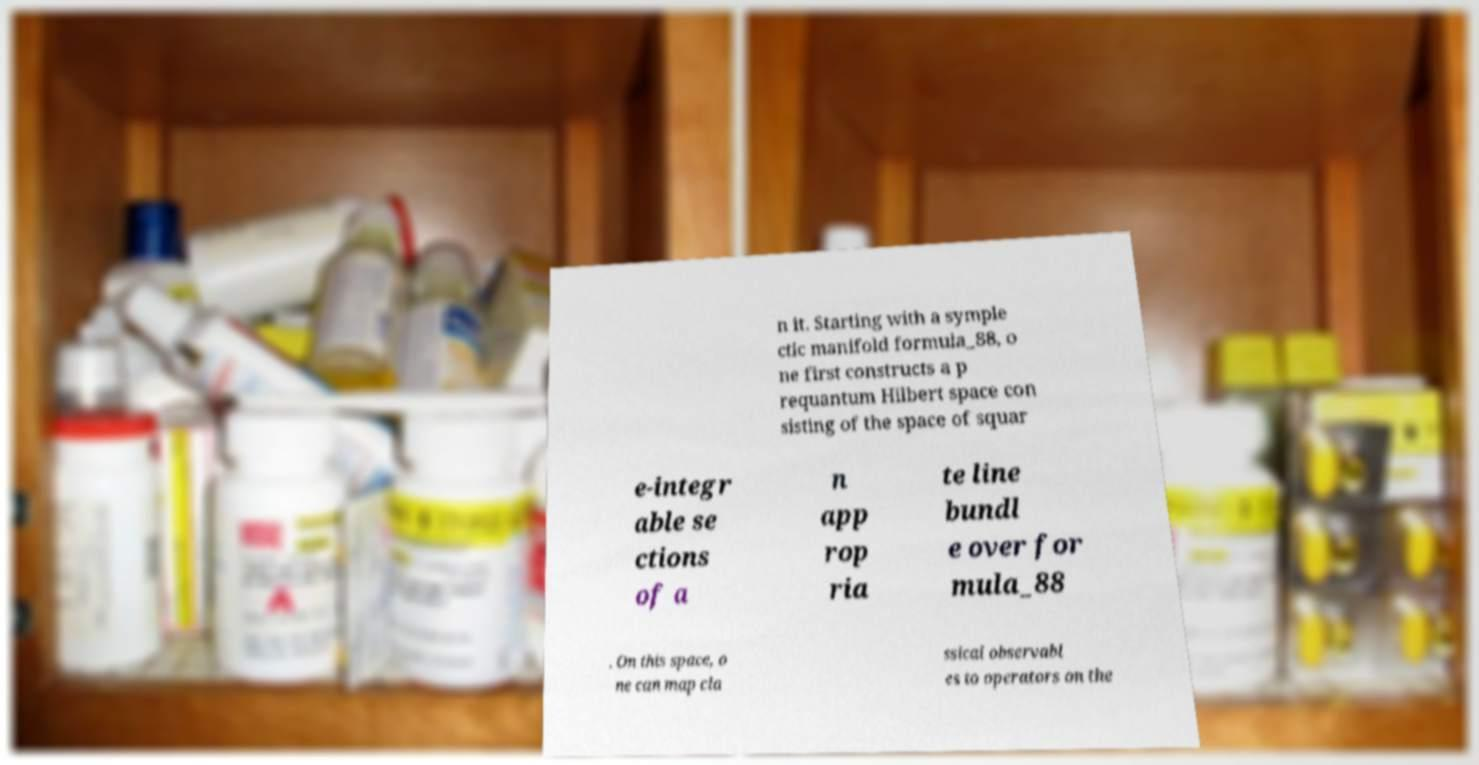There's text embedded in this image that I need extracted. Can you transcribe it verbatim? n it. Starting with a symple ctic manifold formula_88, o ne first constructs a p requantum Hilbert space con sisting of the space of squar e-integr able se ctions of a n app rop ria te line bundl e over for mula_88 . On this space, o ne can map cla ssical observabl es to operators on the 